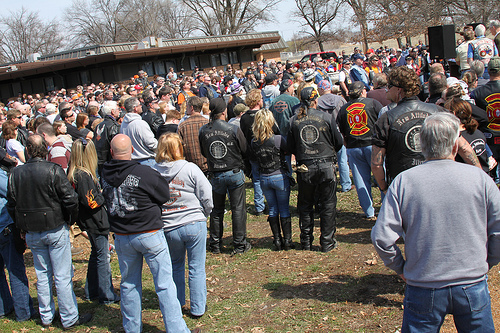<image>
Is there a man on the women? No. The man is not positioned on the women. They may be near each other, but the man is not supported by or resting on top of the women. 